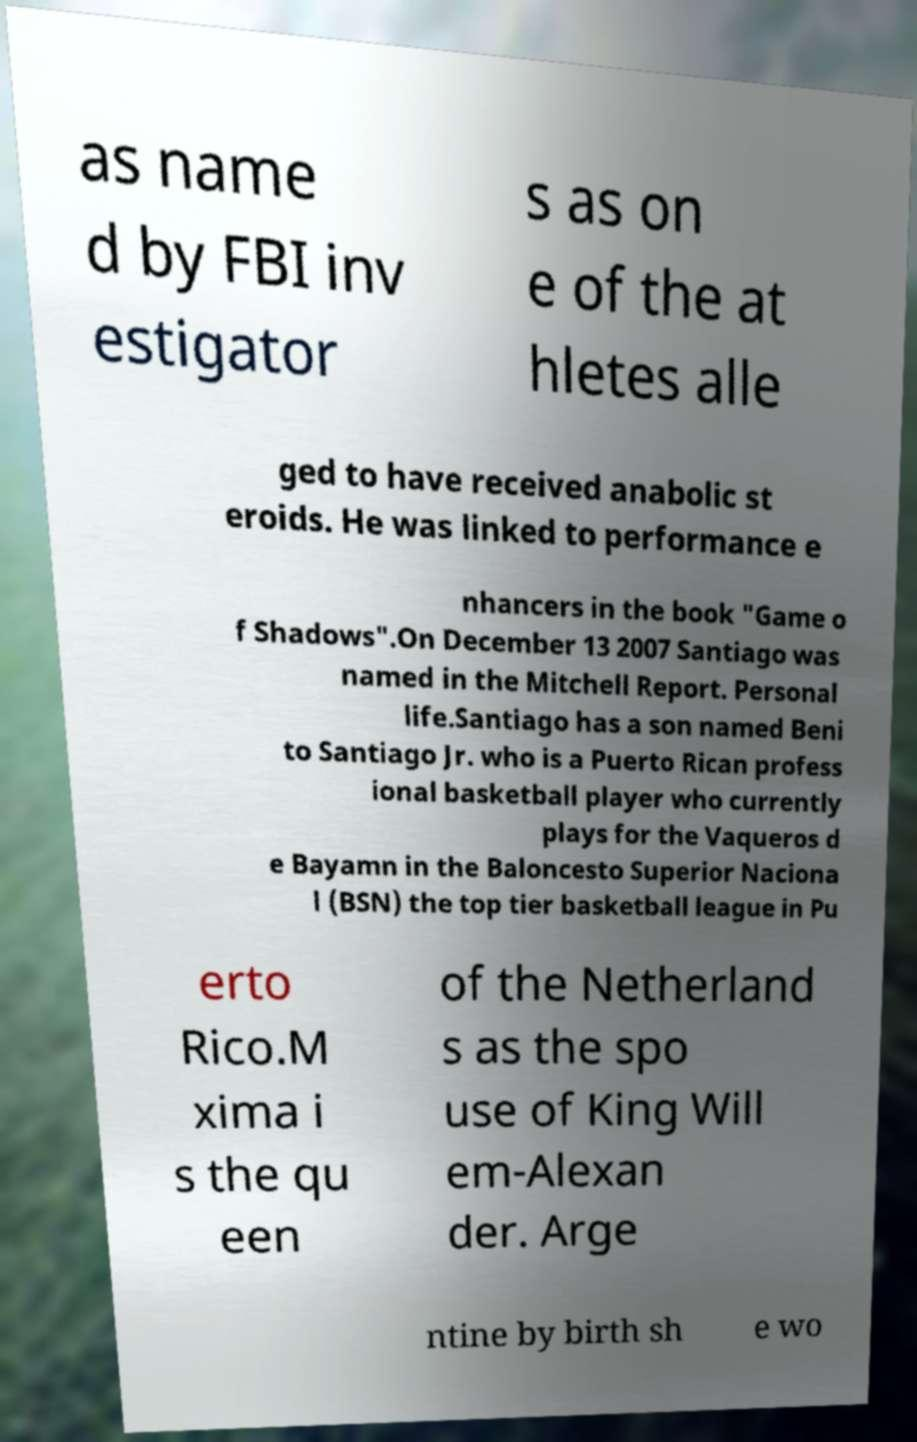Can you accurately transcribe the text from the provided image for me? as name d by FBI inv estigator s as on e of the at hletes alle ged to have received anabolic st eroids. He was linked to performance e nhancers in the book "Game o f Shadows".On December 13 2007 Santiago was named in the Mitchell Report. Personal life.Santiago has a son named Beni to Santiago Jr. who is a Puerto Rican profess ional basketball player who currently plays for the Vaqueros d e Bayamn in the Baloncesto Superior Naciona l (BSN) the top tier basketball league in Pu erto Rico.M xima i s the qu een of the Netherland s as the spo use of King Will em-Alexan der. Arge ntine by birth sh e wo 